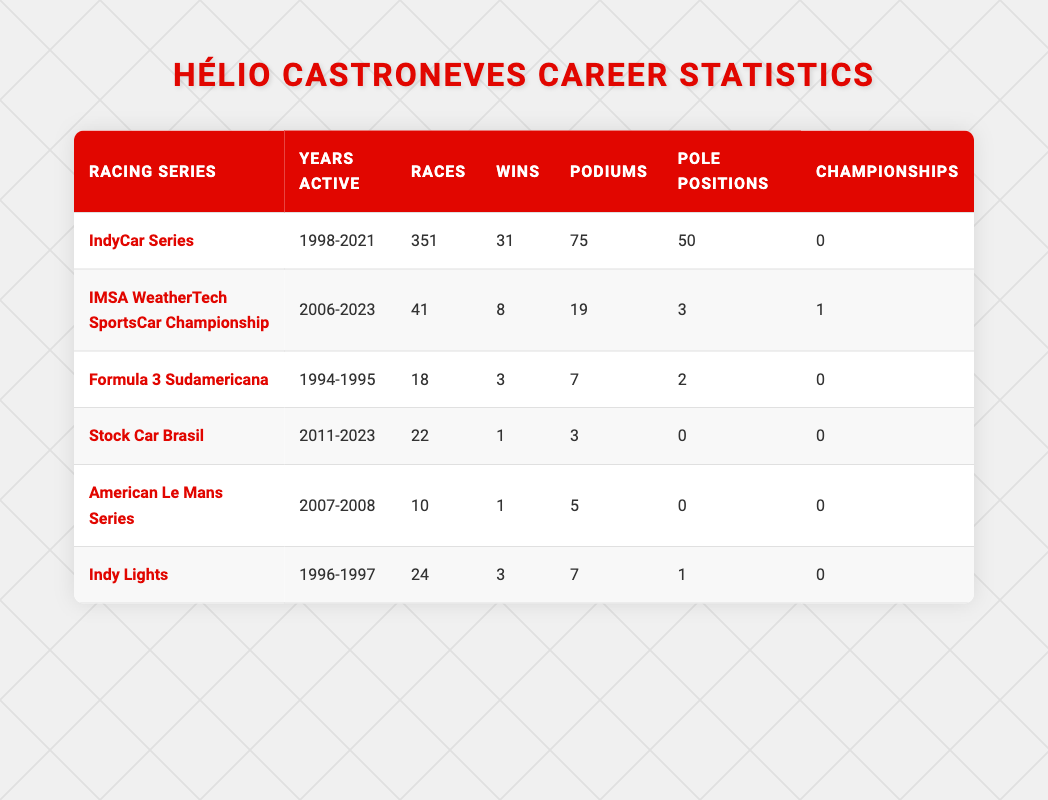What is the total number of races Hélio Castroneves participated in across all series? To find the total number of races, I need to sum the values from the "Races" column. The values are 351 (IndyCar Series) + 41 (IMSA WeatherTech SportsCar Championship) + 18 (Formula 3 Sudamericana) + 22 (Stock Car Brasil) + 10 (American Le Mans Series) + 24 (Indy Lights) = 476.
Answer: 476 How many wins did Hélio have in the IndyCar Series? The "Wins" column for the IndyCar Series shows the value of 31.
Answer: 31 Did Hélio win any championships in the IndyCar Series? The "Championships" column for the IndyCar Series shows the value of 0, indicating that he did not win any championships.
Answer: No Which racing series had the highest number of podium finishes? I will compare the "Podiums" column for each series: 75 (IndyCar Series), 19 (IMSA WeatherTech SportsCar Championship), 7 (Formula 3 Sudamericana), 3 (Stock Car Brasil), 5 (American Le Mans Series), and 7 (Indy Lights). The highest is 75 from the IndyCar Series.
Answer: IndyCar Series What is the average number of wins across all racing series? To find the average, I will sum the wins: 31 + 8 + 3 + 1 + 1 + 3 = 47. There are 6 series, so the average is 47/6 = approximately 7.83.
Answer: 7.83 How many total races did Hélio participate in the IMSA WeatherTech SportsCar Championship and the American Le Mans Series combined? To find this, I will add the races from both series: 41 (IMSA WeatherTech SportsCar Championship) + 10 (American Le Mans Series) = 51.
Answer: 51 Which racing series did Hélio Castroneves participate in for the least number of races? By examining the "Races" column, the minimum value is 10 from the American Le Mans Series, which shows he participated in the least number of races there.
Answer: American Le Mans Series What is the difference between the total wins in the IndyCar Series and the Stock Car Brasil series? To calculate this, I will subtract the number of wins in Stock Car Brasil (1) from the number of wins in IndyCar Series (31): 31 - 1 = 30.
Answer: 30 How many total pole positions did Hélio achieve in both the Indy Lights and IndyCar Series? I will sum the "Pole Positions" for both series: 1 (Indy Lights) + 50 (IndyCar Series) = 51.
Answer: 51 